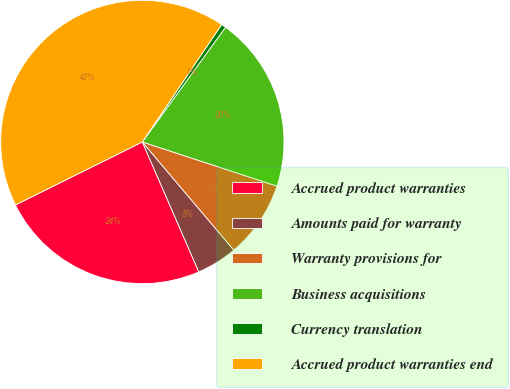<chart> <loc_0><loc_0><loc_500><loc_500><pie_chart><fcel>Accrued product warranties<fcel>Amounts paid for warranty<fcel>Warranty provisions for<fcel>Business acquisitions<fcel>Currency translation<fcel>Accrued product warranties end<nl><fcel>24.19%<fcel>4.65%<fcel>8.78%<fcel>20.06%<fcel>0.53%<fcel>41.79%<nl></chart> 